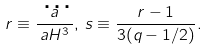Convert formula to latex. <formula><loc_0><loc_0><loc_500><loc_500>r \equiv \frac { \dddot { a } } { a H ^ { 3 } } , \, s \equiv \frac { r - 1 } { 3 ( q - 1 / 2 ) } .</formula> 